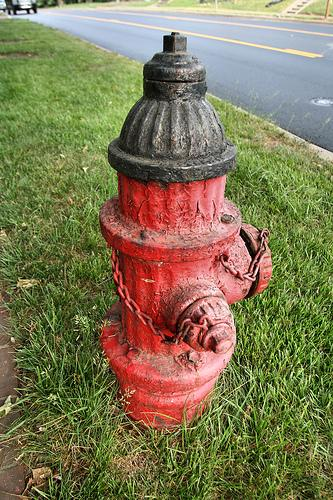Considering visual entailment, describe the image in a way that a person with poor vision would understand it. The image features a red and black fire hydrant with rusty, peeling paint, a red chain connecting its valves, and green grass on either side of the road. Choose the best description for the fire hydrant's location in a referential expression grounding task. The fire hydrant is beside the road, surrounded by green grass, with a red chain connecting its valves. For a product advertisement promoting a paint brand, write a caption addressing the hydrant's paint condition and how the product can help. "Revive your rusty, peeling hydrants with our durable, vibrant paint, perfect for withstanding harsh weather conditions!" Identify any objects besides the fire hydrant that are found on or close to the road. A black car, a utility access, a metal drain cover, and recently painted street lines are all found on or close to the road. For a multi-choice VQA task, what are the objects found on the fire hydrant? Answer 9: C. Black top, red chain What color is the chain connecting the valves on the fire hydrant, and what is its condition? The chain is red, slightly rusted, and painted. What can you say about the state of the grass and its location in relation to the street? The grass is short, vibrant green, recently mowed, and located on either side of the street. In a visual entailment task, describe a scene that contradicts the information presented in the image. A brand-new fire hydrant with pristine, shiny paint, located in a dry, barren area with no grass or road nearby. Describe the condition and color of the fire hydrant. The fire hydrant is red and black, with rusty and peeling paint in poor repair. Based on the image, what can be inferred about the maintenance of the surrounding area? The surrounding area is well-maintained with recently mowed grass, freshly paved blacktop, and newly painted street lines. 